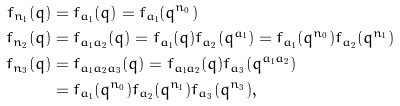<formula> <loc_0><loc_0><loc_500><loc_500>f _ { n _ { 1 } } ( q ) & = f _ { a _ { 1 } } ( q ) = f _ { a _ { 1 } } ( q ^ { n _ { 0 } } ) \\ f _ { n _ { 2 } } ( q ) & = f _ { a _ { 1 } a _ { 2 } } ( q ) = f _ { a _ { 1 } } ( q ) f _ { a _ { 2 } } ( q ^ { a _ { 1 } } ) = f _ { a _ { 1 } } ( q ^ { n _ { 0 } } ) f _ { a _ { 2 } } ( q ^ { n _ { 1 } } ) \\ f _ { n _ { 3 } } ( q ) & = f _ { a _ { 1 } a _ { 2 } a _ { 3 } } ( q ) = f _ { a _ { 1 } a _ { 2 } } ( q ) f _ { a _ { 3 } } ( q ^ { a _ { 1 } a _ { 2 } } ) \\ & = f _ { a _ { 1 } } ( q ^ { n _ { 0 } } ) f _ { a _ { 2 } } ( q ^ { n _ { 1 } } ) f _ { a _ { 3 } } ( q ^ { n _ { 3 } } ) ,</formula> 